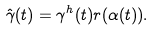<formula> <loc_0><loc_0><loc_500><loc_500>\hat { \gamma } ( t ) = \gamma ^ { h } ( t ) r ( \alpha ( t ) ) .</formula> 